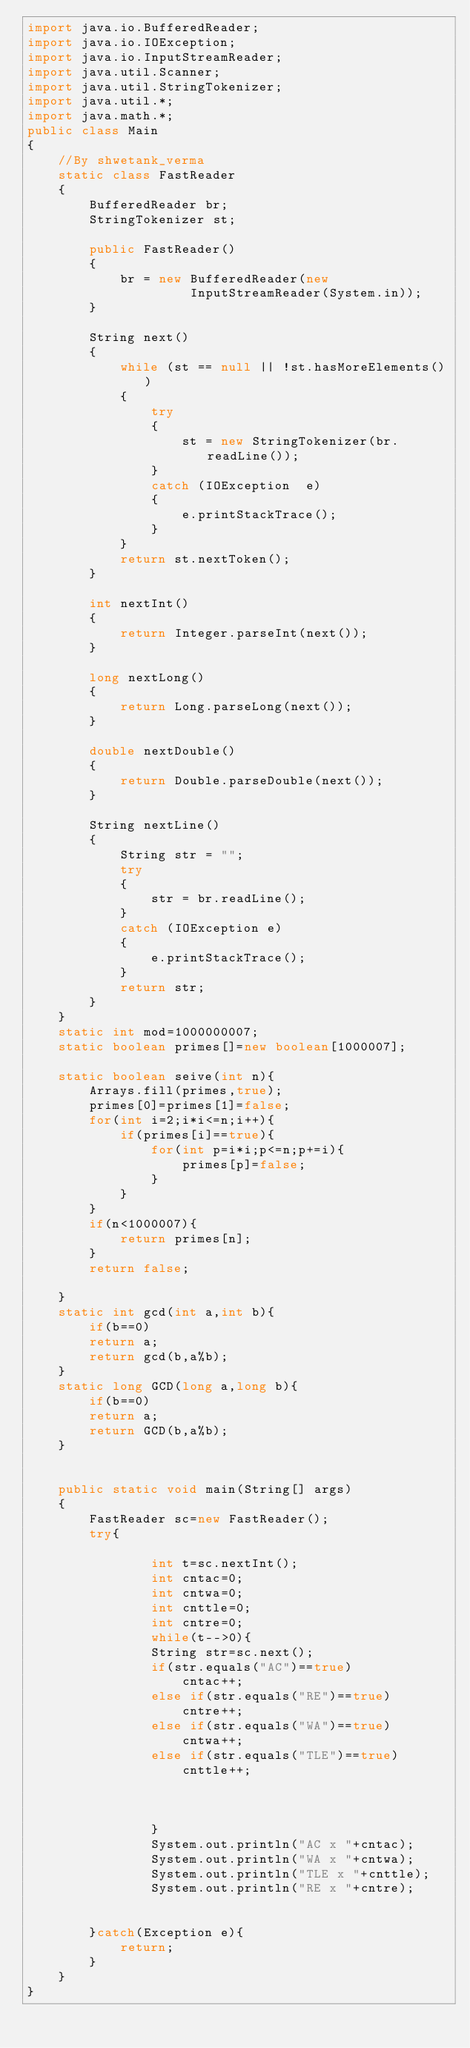Convert code to text. <code><loc_0><loc_0><loc_500><loc_500><_Java_>import java.io.BufferedReader; 
import java.io.IOException; 
import java.io.InputStreamReader; 
import java.util.Scanner; 
import java.util.StringTokenizer; 
import java.util.*;
import java.math.*;  
public class Main
{ 
    //By shwetank_verma
    static class FastReader 
    { 
        BufferedReader br; 
        StringTokenizer st; 
  
        public FastReader() 
        { 
            br = new BufferedReader(new
                     InputStreamReader(System.in)); 
        } 
  
        String next() 
        { 
            while (st == null || !st.hasMoreElements()) 
            { 
                try
                { 
                    st = new StringTokenizer(br.readLine()); 
                } 
                catch (IOException  e) 
                { 
                    e.printStackTrace(); 
                } 
            } 
            return st.nextToken(); 
        } 
  
        int nextInt() 
        { 
            return Integer.parseInt(next()); 
        } 
  
        long nextLong() 
        { 
            return Long.parseLong(next()); 
        } 
  
        double nextDouble() 
        { 
            return Double.parseDouble(next()); 
        } 
  
        String nextLine() 
        { 
            String str = ""; 
            try
            { 
                str = br.readLine(); 
            } 
            catch (IOException e) 
            { 
                e.printStackTrace(); 
            } 
            return str; 
        } 
    } 
    static int mod=1000000007;
    static boolean primes[]=new boolean[1000007];
    
    static boolean seive(int n){
        Arrays.fill(primes,true);
        primes[0]=primes[1]=false;
        for(int i=2;i*i<=n;i++){
            if(primes[i]==true){
                for(int p=i*i;p<=n;p+=i){
                    primes[p]=false;
                }
            }
        }
        if(n<1000007){
            return primes[n];
        }
        return false;
        
    }
    static int gcd(int a,int b){
        if(b==0)
        return a;
        return gcd(b,a%b);
    }
    static long GCD(long a,long b){
        if(b==0)
        return a;
        return GCD(b,a%b);
    }
    
  
    public static void main(String[] args) 
    { 
        FastReader sc=new FastReader(); 
        try{
           
                int t=sc.nextInt();
                int cntac=0;
                int cntwa=0;
                int cnttle=0;
                int cntre=0;
                while(t-->0){
                String str=sc.next();
                if(str.equals("AC")==true)
                	cntac++;
                else if(str.equals("RE")==true)
                	cntre++;
                else if(str.equals("WA")==true)
                	cntwa++;
                else if(str.equals("TLE")==true)
                	cnttle++;
                
                
        
                }
                System.out.println("AC x "+cntac);
                System.out.println("WA x "+cntwa);
                System.out.println("TLE x "+cnttle);
                System.out.println("RE x "+cntre);
           
            
        }catch(Exception e){
            return;
        }
    } 
}</code> 